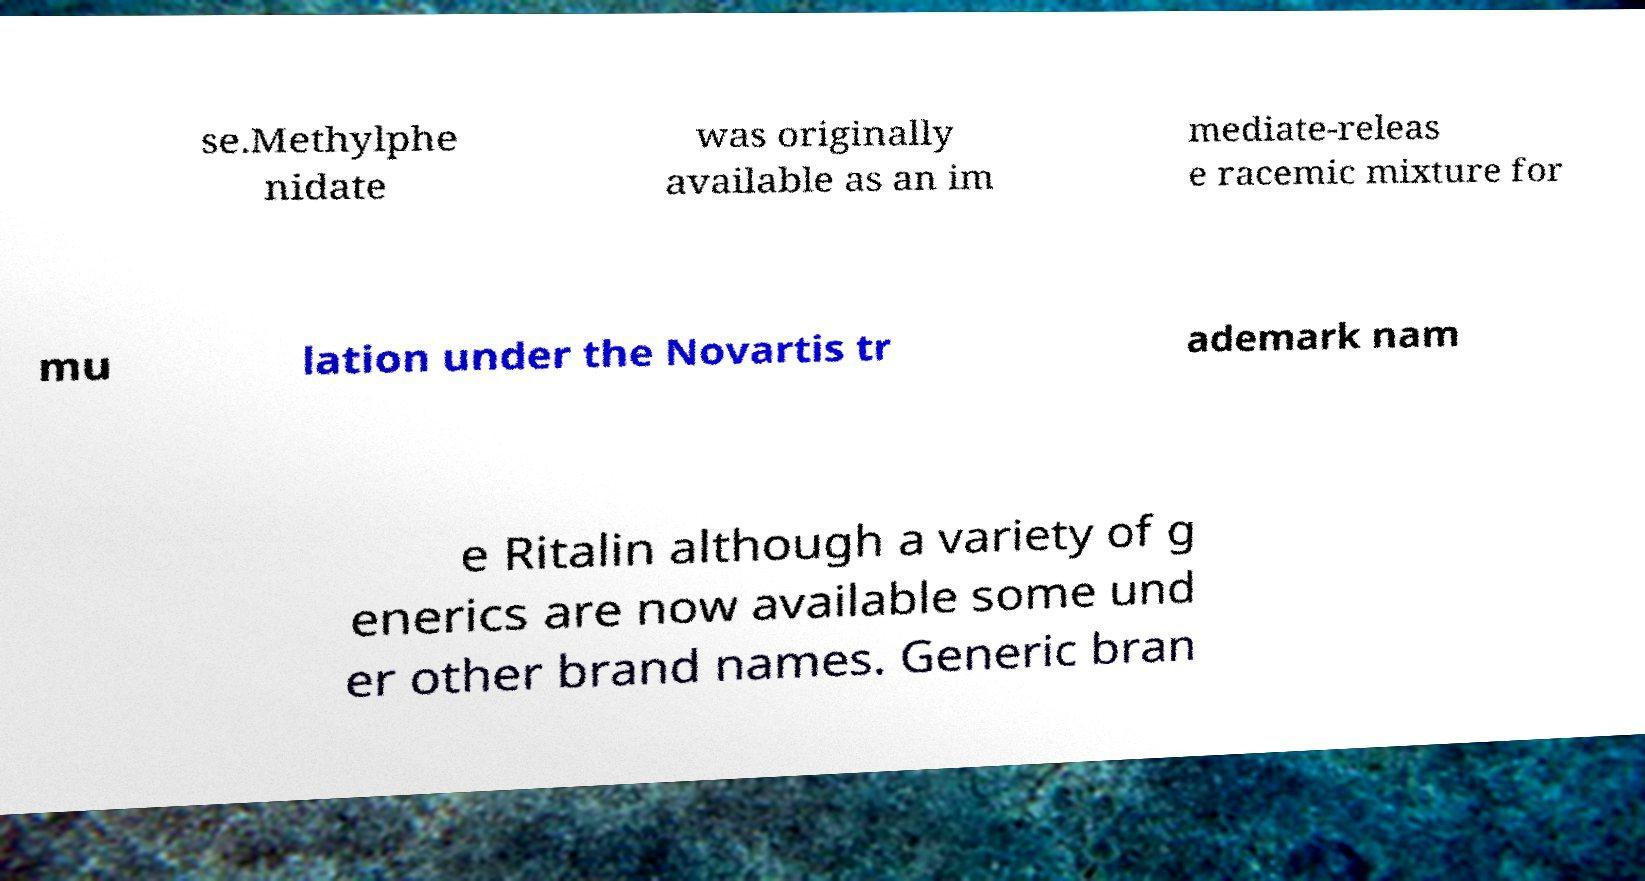Can you accurately transcribe the text from the provided image for me? se.Methylphe nidate was originally available as an im mediate-releas e racemic mixture for mu lation under the Novartis tr ademark nam e Ritalin although a variety of g enerics are now available some und er other brand names. Generic bran 